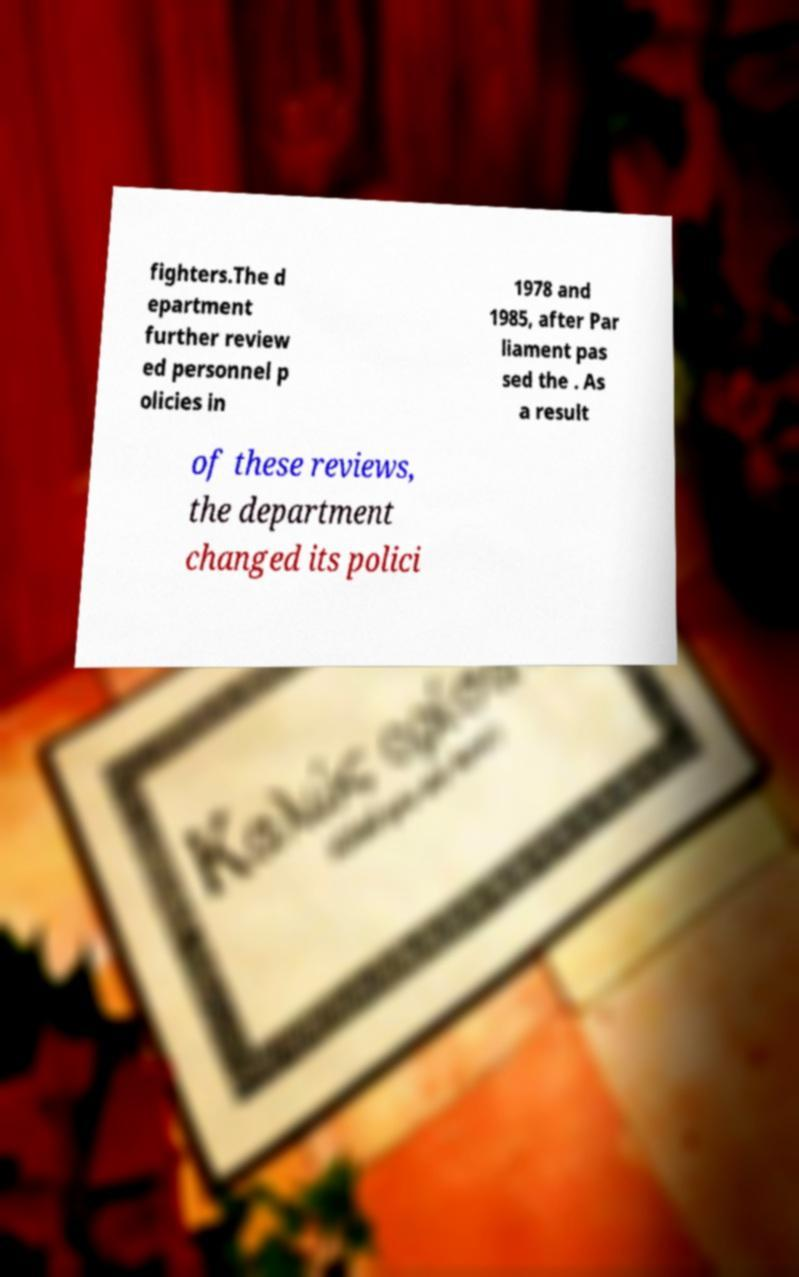Can you accurately transcribe the text from the provided image for me? fighters.The d epartment further review ed personnel p olicies in 1978 and 1985, after Par liament pas sed the . As a result of these reviews, the department changed its polici 